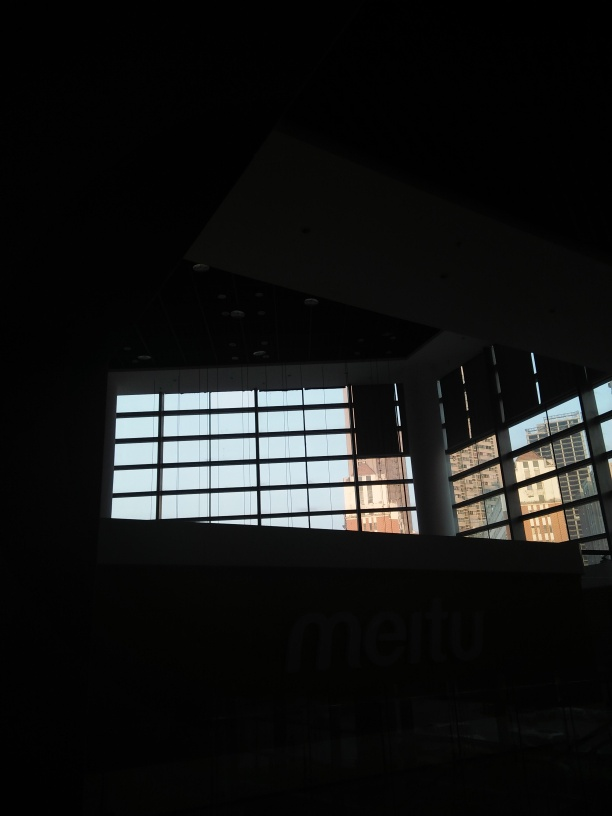Despite the underexposure, can you describe the view outside the window? The view through the window, although dimly lit, reveals a cityscape with buildings of varying heights. The silhouettes of these structures create a layered urban skyline. No specific details can be distinguished due to the underexposure, but it suggests a developed, possibly dense urban area. 